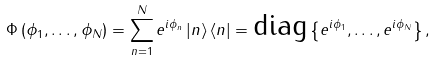<formula> <loc_0><loc_0><loc_500><loc_500>\Phi \left ( \phi _ { 1 } , \dots , \phi _ { N } \right ) = \sum _ { n = 1 } ^ { N } e ^ { i \phi _ { n } } \left | n \right \rangle \left \langle n \right | = \text {diag} \left \{ e ^ { i \phi _ { 1 } } , \dots , e ^ { i \phi _ { N } } \right \} ,</formula> 